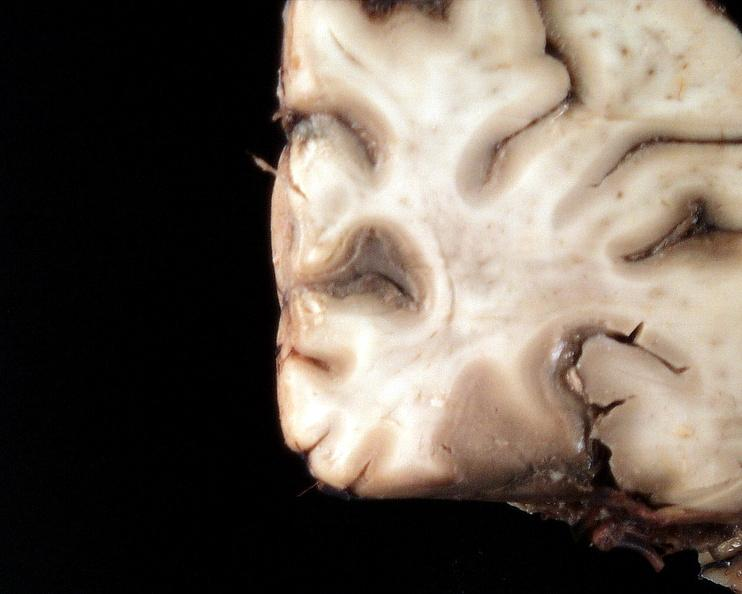does opened base of skull with brain show brain, cryptococcal meningitis?
Answer the question using a single word or phrase. No 